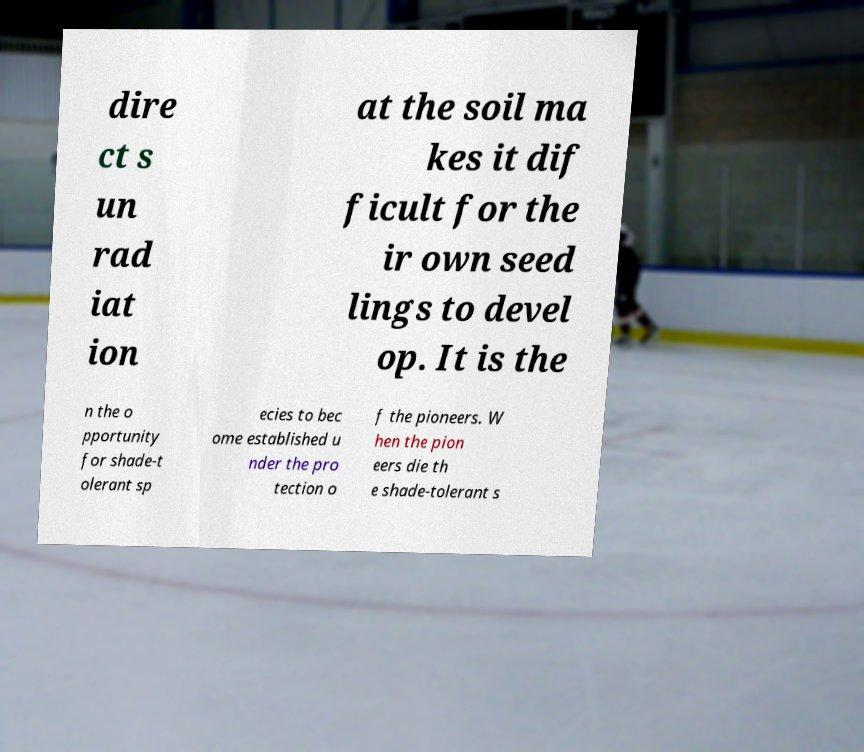What messages or text are displayed in this image? I need them in a readable, typed format. dire ct s un rad iat ion at the soil ma kes it dif ficult for the ir own seed lings to devel op. It is the n the o pportunity for shade-t olerant sp ecies to bec ome established u nder the pro tection o f the pioneers. W hen the pion eers die th e shade-tolerant s 